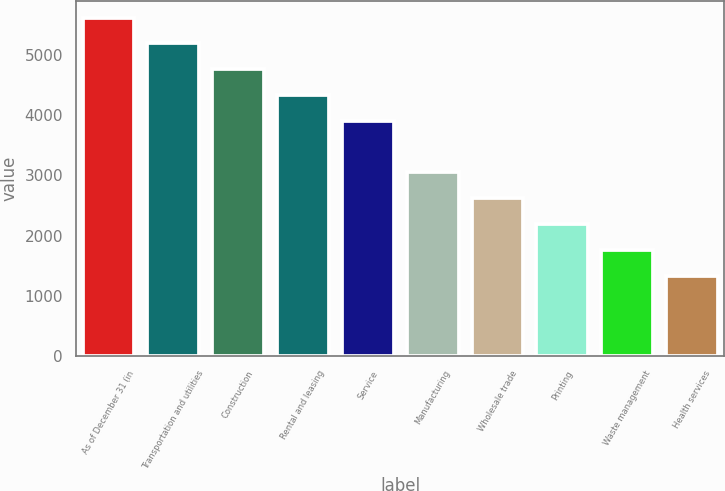Convert chart to OTSL. <chart><loc_0><loc_0><loc_500><loc_500><bar_chart><fcel>As of December 31 (in<fcel>Transportation and utilities<fcel>Construction<fcel>Rental and leasing<fcel>Service<fcel>Manufacturing<fcel>Wholesale trade<fcel>Printing<fcel>Waste management<fcel>Health services<nl><fcel>5626.8<fcel>5197.6<fcel>4768.4<fcel>4339.2<fcel>3910<fcel>3051.6<fcel>2622.4<fcel>2193.2<fcel>1764<fcel>1334.8<nl></chart> 